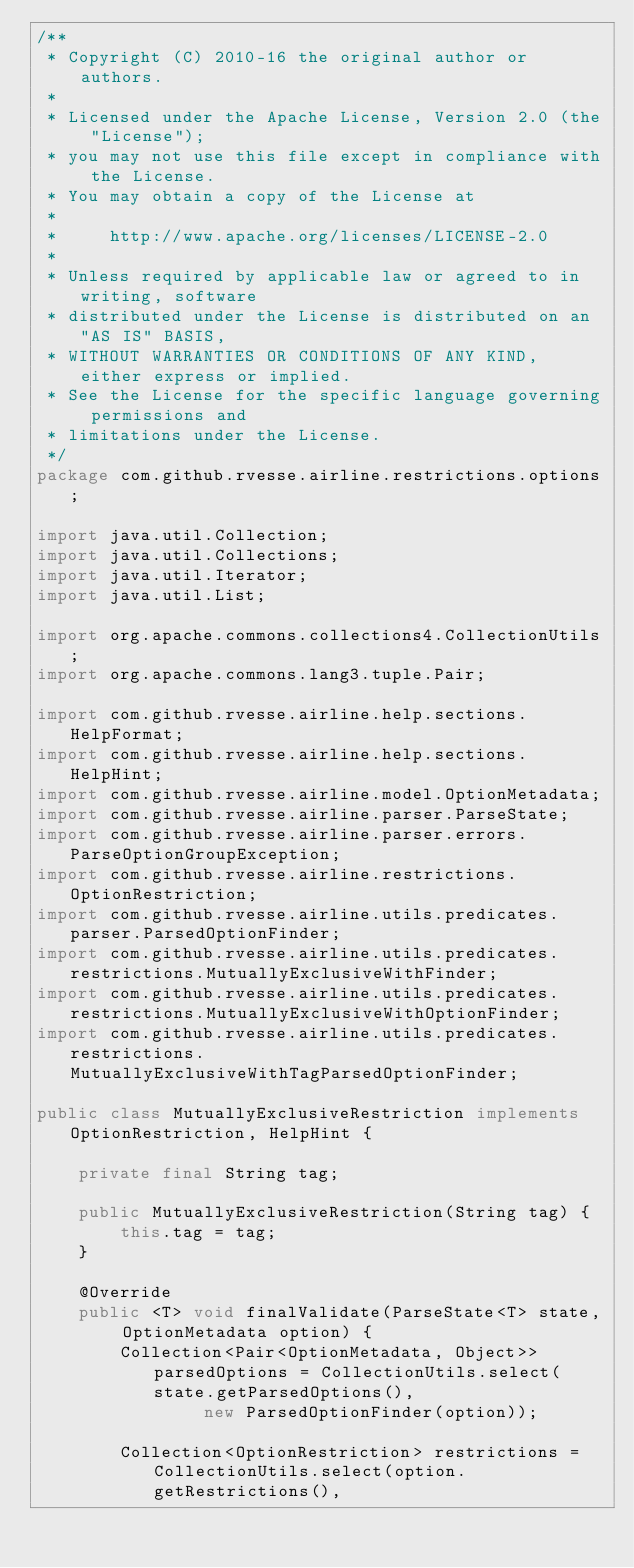Convert code to text. <code><loc_0><loc_0><loc_500><loc_500><_Java_>/**
 * Copyright (C) 2010-16 the original author or authors.
 *
 * Licensed under the Apache License, Version 2.0 (the "License");
 * you may not use this file except in compliance with the License.
 * You may obtain a copy of the License at
 *
 *     http://www.apache.org/licenses/LICENSE-2.0
 *
 * Unless required by applicable law or agreed to in writing, software
 * distributed under the License is distributed on an "AS IS" BASIS,
 * WITHOUT WARRANTIES OR CONDITIONS OF ANY KIND, either express or implied.
 * See the License for the specific language governing permissions and
 * limitations under the License.
 */
package com.github.rvesse.airline.restrictions.options;

import java.util.Collection;
import java.util.Collections;
import java.util.Iterator;
import java.util.List;

import org.apache.commons.collections4.CollectionUtils;
import org.apache.commons.lang3.tuple.Pair;

import com.github.rvesse.airline.help.sections.HelpFormat;
import com.github.rvesse.airline.help.sections.HelpHint;
import com.github.rvesse.airline.model.OptionMetadata;
import com.github.rvesse.airline.parser.ParseState;
import com.github.rvesse.airline.parser.errors.ParseOptionGroupException;
import com.github.rvesse.airline.restrictions.OptionRestriction;
import com.github.rvesse.airline.utils.predicates.parser.ParsedOptionFinder;
import com.github.rvesse.airline.utils.predicates.restrictions.MutuallyExclusiveWithFinder;
import com.github.rvesse.airline.utils.predicates.restrictions.MutuallyExclusiveWithOptionFinder;
import com.github.rvesse.airline.utils.predicates.restrictions.MutuallyExclusiveWithTagParsedOptionFinder;

public class MutuallyExclusiveRestriction implements OptionRestriction, HelpHint {

    private final String tag;

    public MutuallyExclusiveRestriction(String tag) {
        this.tag = tag;
    }

    @Override
    public <T> void finalValidate(ParseState<T> state, OptionMetadata option) {
        Collection<Pair<OptionMetadata, Object>> parsedOptions = CollectionUtils.select(state.getParsedOptions(),
                new ParsedOptionFinder(option));

        Collection<OptionRestriction> restrictions = CollectionUtils.select(option.getRestrictions(),</code> 